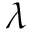Convert formula to latex. <formula><loc_0><loc_0><loc_500><loc_500>\lambda</formula> 